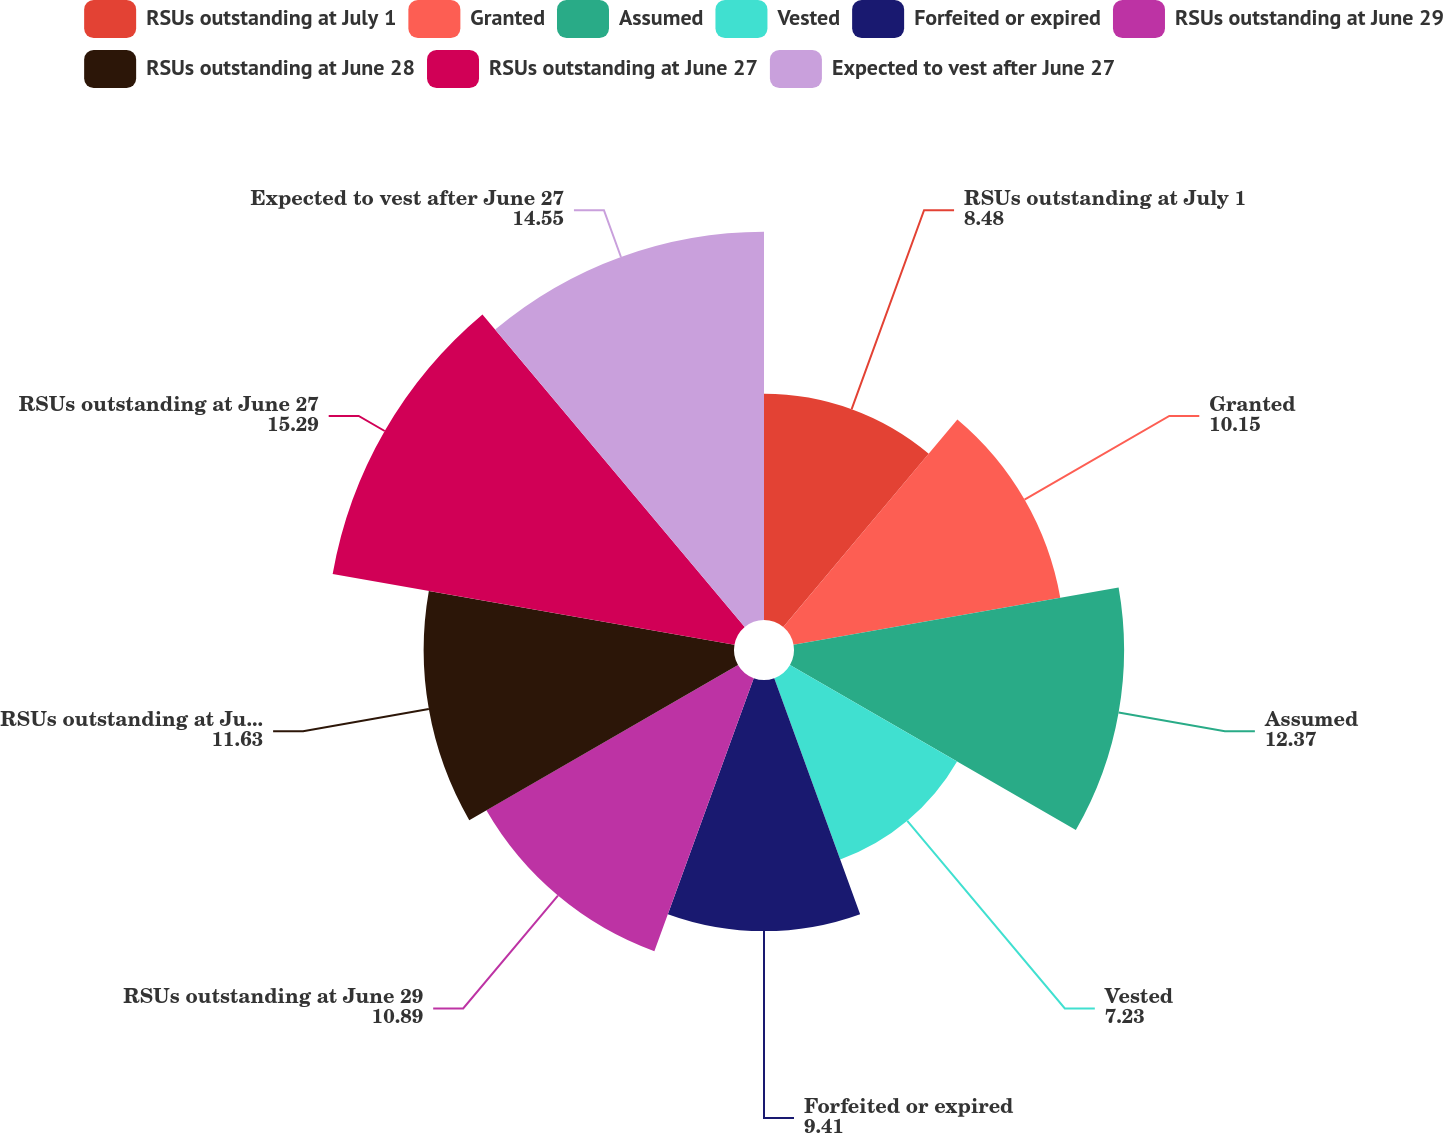Convert chart. <chart><loc_0><loc_0><loc_500><loc_500><pie_chart><fcel>RSUs outstanding at July 1<fcel>Granted<fcel>Assumed<fcel>Vested<fcel>Forfeited or expired<fcel>RSUs outstanding at June 29<fcel>RSUs outstanding at June 28<fcel>RSUs outstanding at June 27<fcel>Expected to vest after June 27<nl><fcel>8.48%<fcel>10.15%<fcel>12.37%<fcel>7.23%<fcel>9.41%<fcel>10.89%<fcel>11.63%<fcel>15.29%<fcel>14.55%<nl></chart> 